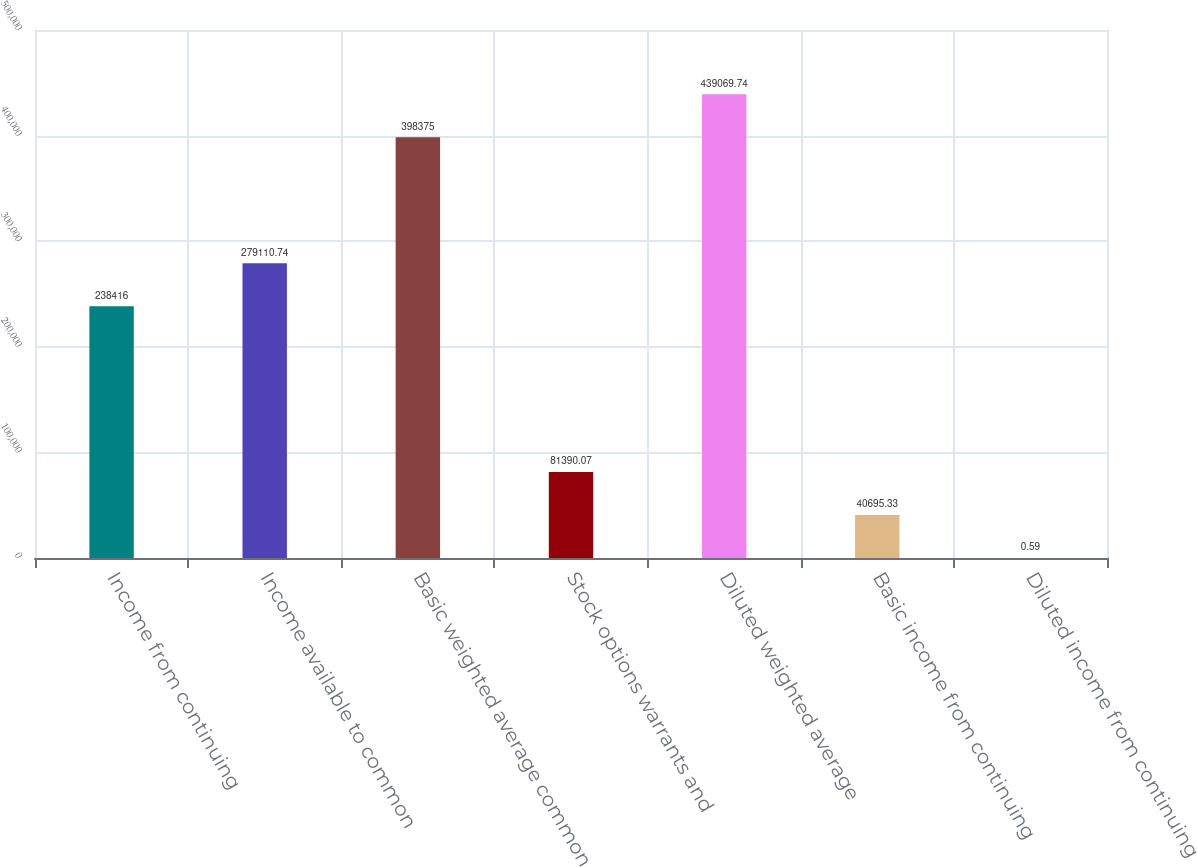Convert chart to OTSL. <chart><loc_0><loc_0><loc_500><loc_500><bar_chart><fcel>Income from continuing<fcel>Income available to common<fcel>Basic weighted average common<fcel>Stock options warrants and<fcel>Diluted weighted average<fcel>Basic income from continuing<fcel>Diluted income from continuing<nl><fcel>238416<fcel>279111<fcel>398375<fcel>81390.1<fcel>439070<fcel>40695.3<fcel>0.59<nl></chart> 